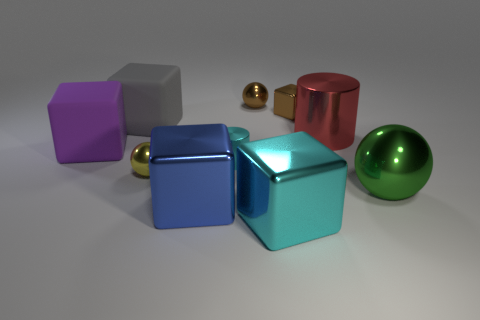How does the lighting in the scene affect the appearance of the objects? The lighting plays a significant role in this scene. It casts soft shadows and highlights the reflective qualities of the metallic surfaces, creating a sense of depth and dimensionality. The way light reflects off each object also helps us perceive their shapes and textures, enhancing the overall visual experience. 